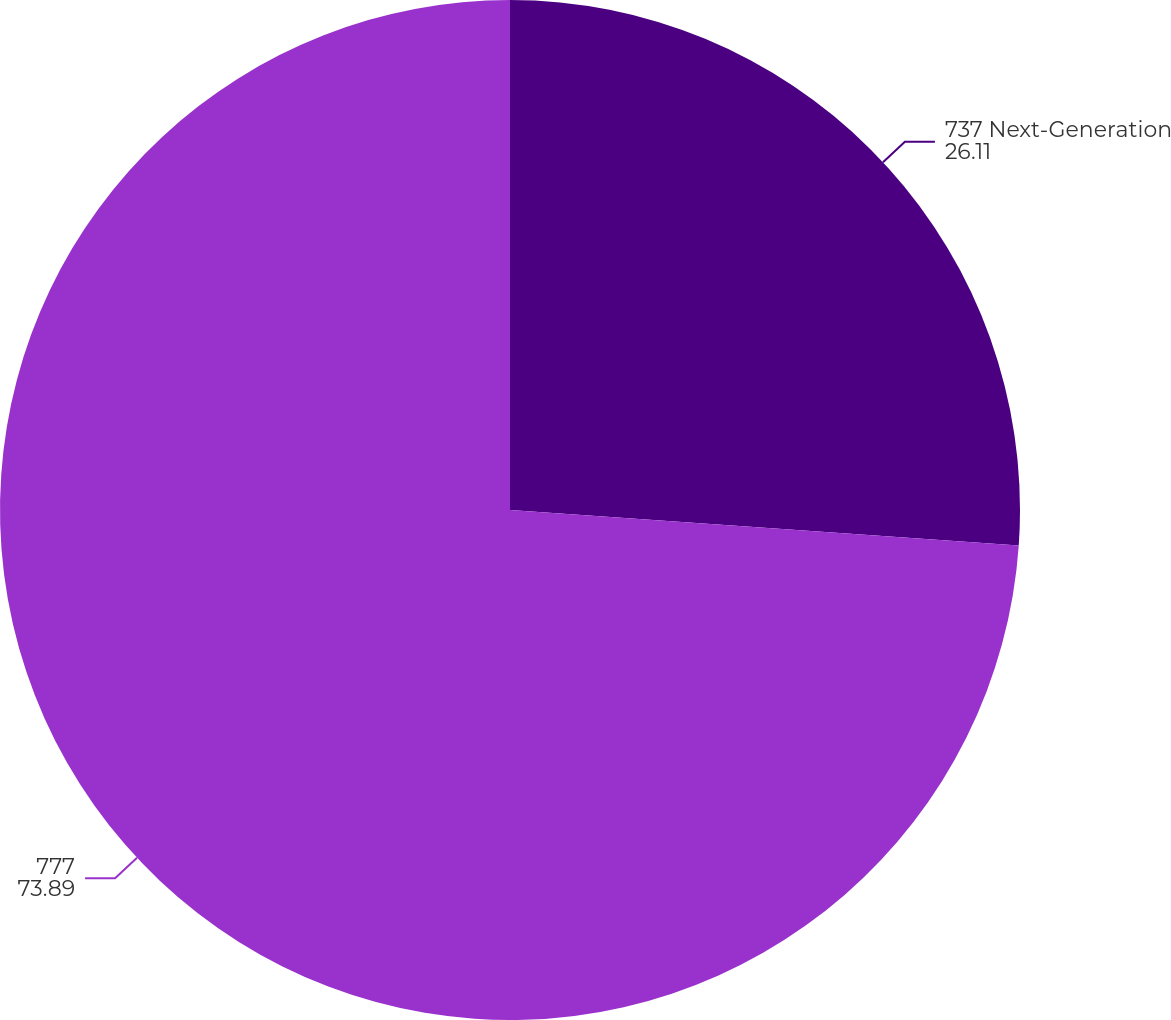Convert chart to OTSL. <chart><loc_0><loc_0><loc_500><loc_500><pie_chart><fcel>737 Next-Generation<fcel>777<nl><fcel>26.11%<fcel>73.89%<nl></chart> 